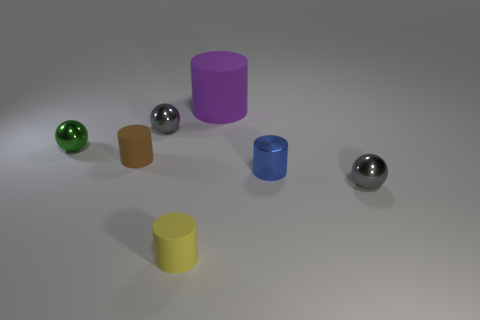Do the small green metallic thing and the blue metallic thing have the same shape?
Your answer should be very brief. No. How many spheres are made of the same material as the yellow cylinder?
Give a very brief answer. 0. There is a purple thing that is the same shape as the blue shiny thing; what size is it?
Your answer should be very brief. Large. Do the yellow matte cylinder and the metal cylinder have the same size?
Give a very brief answer. Yes. What shape is the tiny matte object that is in front of the small rubber thing that is on the left side of the gray ball that is behind the brown rubber cylinder?
Your answer should be very brief. Cylinder. What is the color of the small metallic thing that is the same shape as the large matte thing?
Offer a very short reply. Blue. There is a object that is in front of the big purple rubber thing and behind the green object; how big is it?
Offer a very short reply. Small. There is a rubber object in front of the tiny object that is on the right side of the tiny blue metallic cylinder; what number of small blue shiny cylinders are right of it?
Make the answer very short. 1. How many tiny objects are either green metallic cylinders or shiny balls?
Your response must be concise. 3. Does the tiny cylinder right of the purple thing have the same material as the green sphere?
Your response must be concise. Yes. 